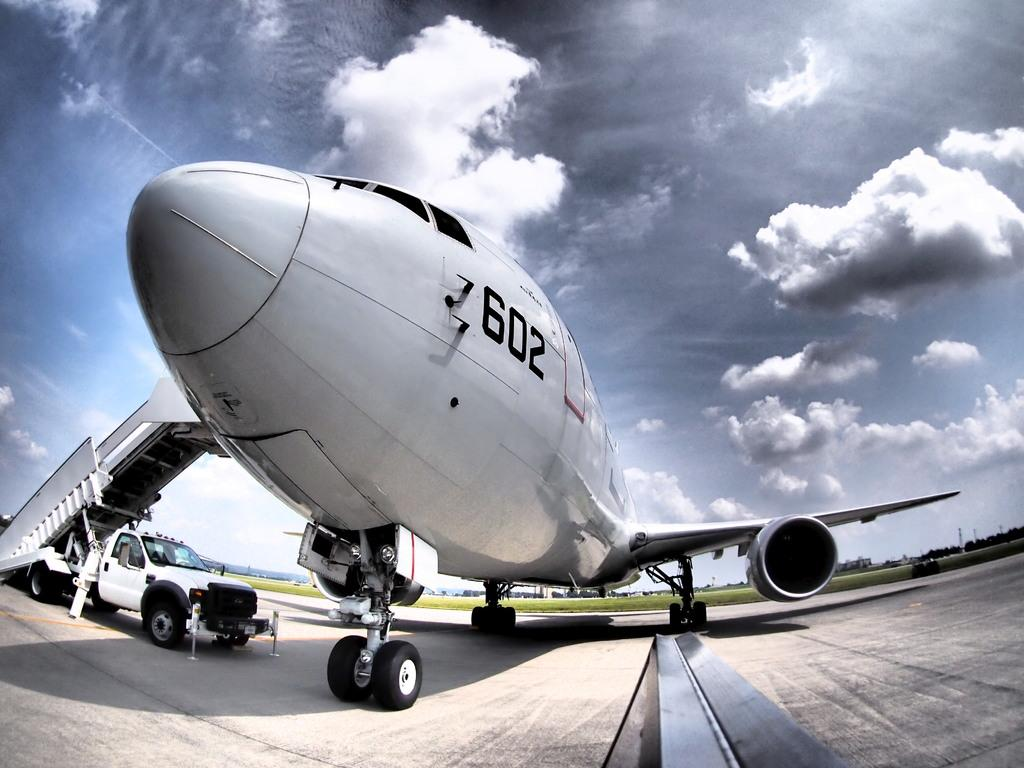<image>
Relay a brief, clear account of the picture shown. A jet airplane has the number 602 near its nose. 